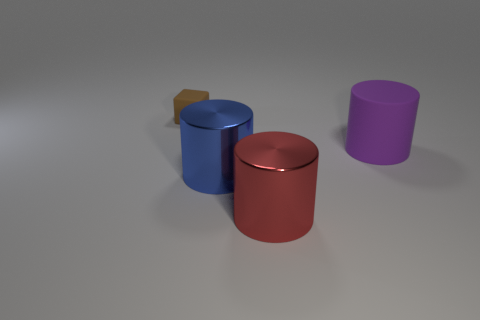Subtract all red shiny cylinders. How many cylinders are left? 2 Subtract all blue cylinders. How many cylinders are left? 2 Add 4 cyan rubber cylinders. How many objects exist? 8 Add 1 big things. How many big things are left? 4 Add 1 red matte cubes. How many red matte cubes exist? 1 Subtract 0 gray blocks. How many objects are left? 4 Subtract all cubes. How many objects are left? 3 Subtract all green cylinders. Subtract all gray cubes. How many cylinders are left? 3 Subtract all yellow balls. How many gray blocks are left? 0 Subtract all big blue cylinders. Subtract all big metallic objects. How many objects are left? 1 